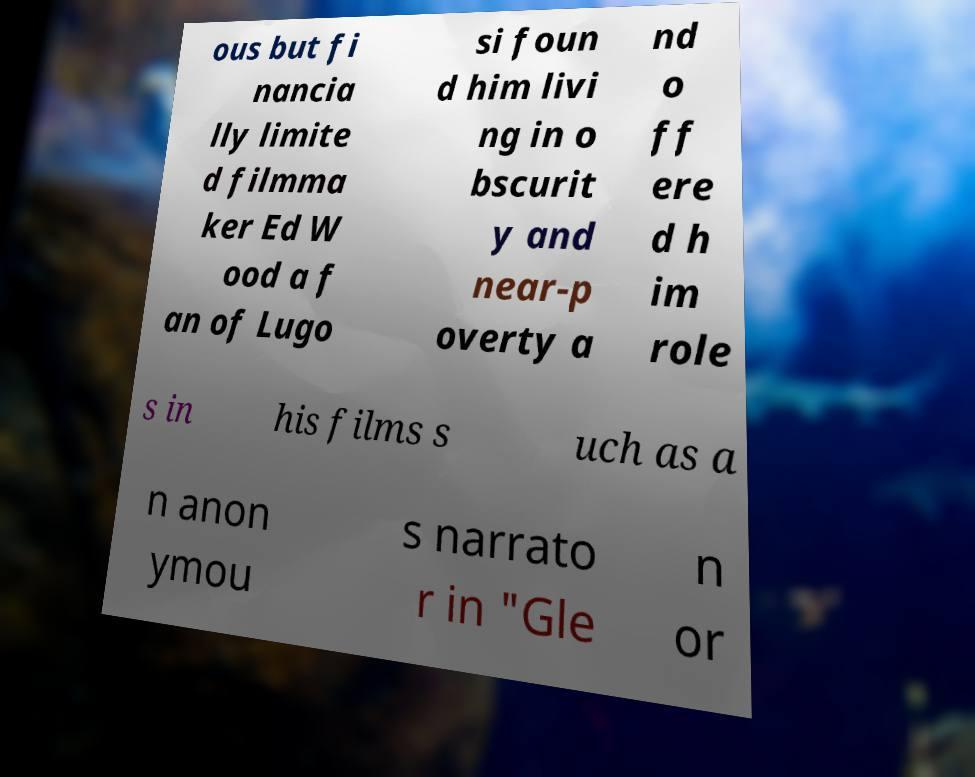Please identify and transcribe the text found in this image. ous but fi nancia lly limite d filmma ker Ed W ood a f an of Lugo si foun d him livi ng in o bscurit y and near-p overty a nd o ff ere d h im role s in his films s uch as a n anon ymou s narrato r in "Gle n or 